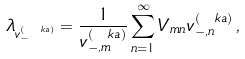Convert formula to latex. <formula><loc_0><loc_0><loc_500><loc_500>\lambda _ { v _ { - } ^ { ( \ k a ) } } = \frac { 1 } { v _ { - , m } ^ { ( \ k a ) } } \sum _ { n = 1 } ^ { \infty } V _ { m n } v _ { - , n } ^ { ( \ k a ) } \, ,</formula> 